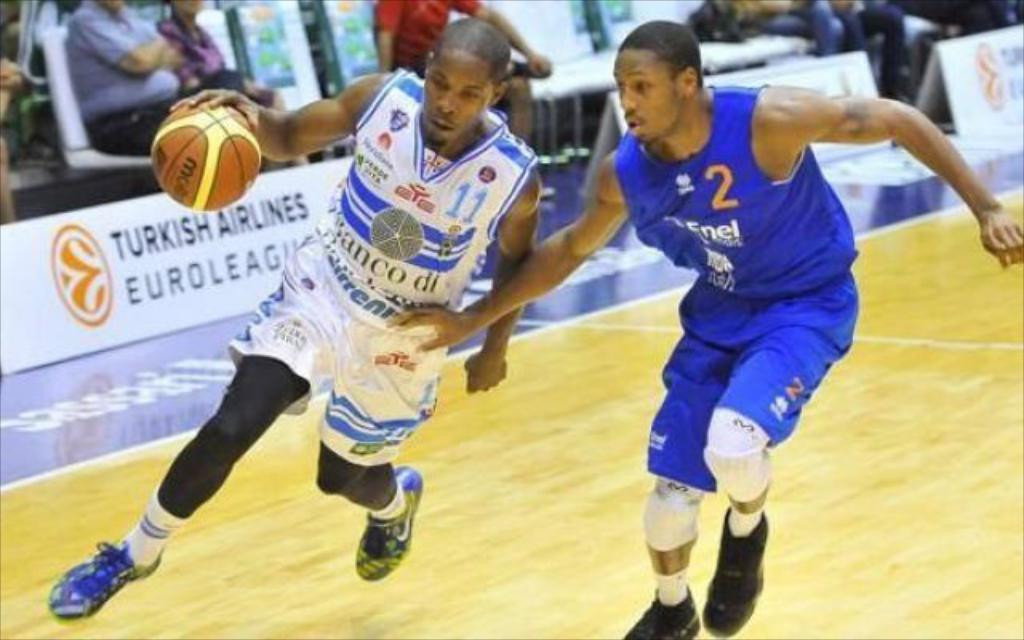What are the two people in the image doing? The two people in the image are playing basketball. Can you describe the setting of the image? In the background, there are people sitting and watching the game. How many apples are on the court during the basketball game? There are no apples present on the court during the basketball game. What type of clam is visible in the image? There is no clam visible in the image; it features a basketball game. 